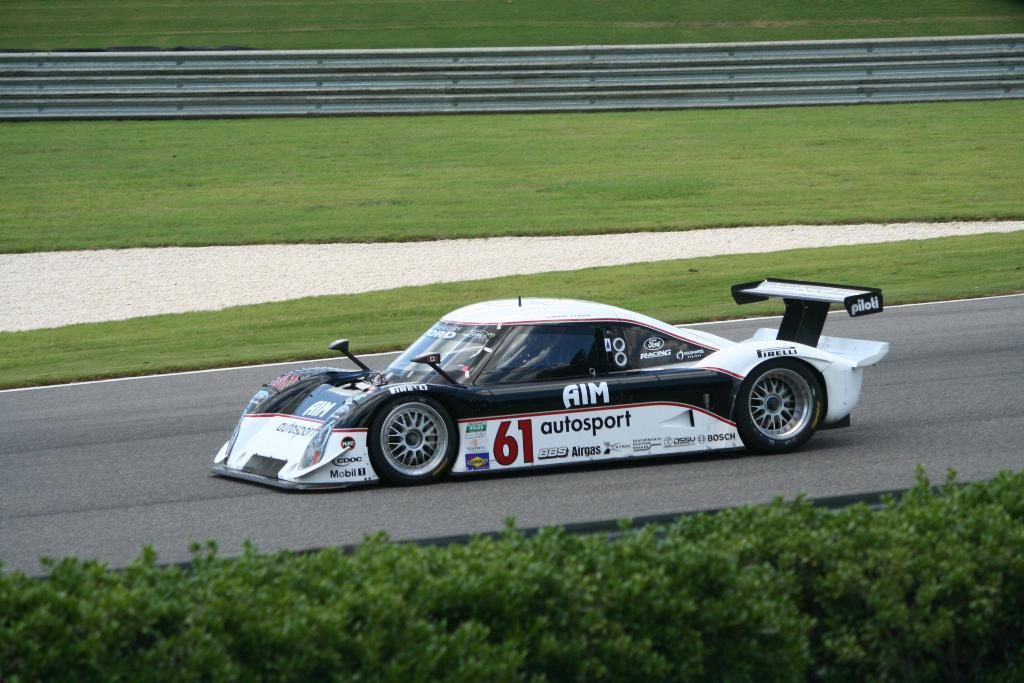What type of vehicle is on the road in the image? There is a sports car on the road in the image. What type of vegetation can be seen in the image? There is grass and plants visible in the image. What material is present in the image? There is an iron sheet in the image. What type of credit card is being used to purchase the sports car in the image? There is no credit card or purchase being depicted in the image; it simply shows a sports car on the road. 